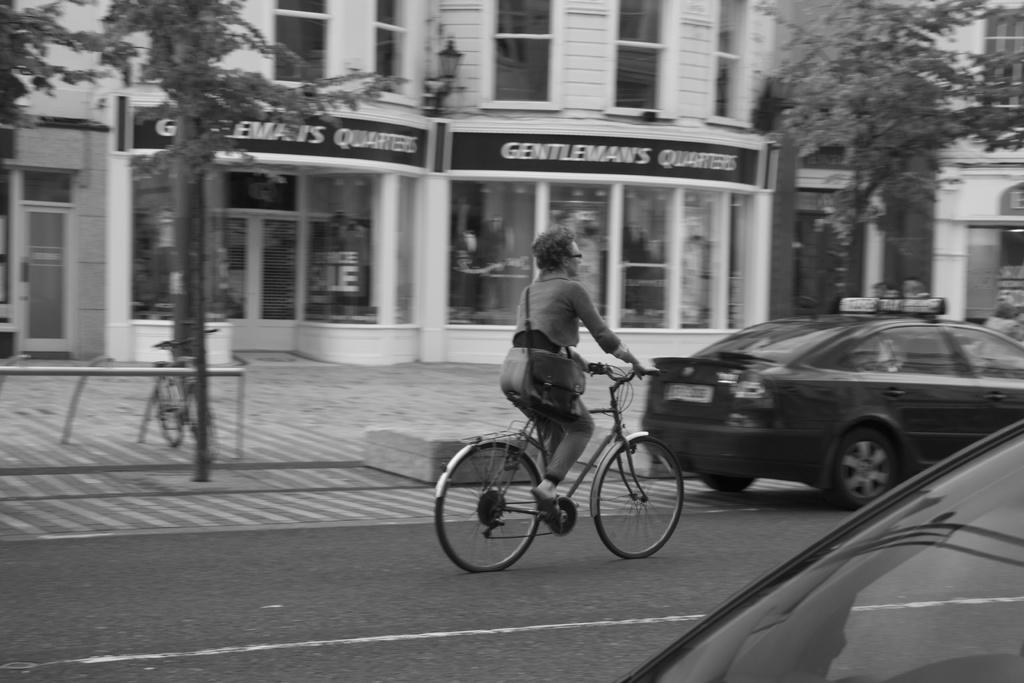What is the person in the image doing? The person is cycling in the image. What mode of transportation is the person using? The person is riding a cycle. Can you describe any accessories the person is wearing? The person is wearing glasses (specs). What else can be seen in the image besides the person cycling? There is a bag visible in the image, and there are vehicles, another cycle, trees, and buildings in the background of the image. How many lizards can be seen crawling on the cycle in the image? There are no lizards present in the image; the person is riding a cycle without any lizards. 